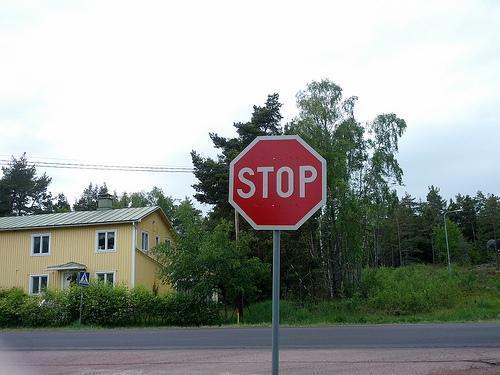How many stop signs are there?
Give a very brief answer. 1. How many houses are in the photo?
Give a very brief answer. 1. 